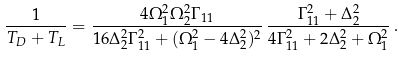Convert formula to latex. <formula><loc_0><loc_0><loc_500><loc_500>\frac { 1 } { T _ { D } + T _ { L } } = \frac { 4 \Omega _ { 1 } ^ { 2 } \Omega _ { 2 } ^ { 2 } \Gamma _ { 1 1 } } { 1 6 \Delta _ { 2 } ^ { 2 } \Gamma _ { 1 1 } ^ { 2 } + ( \Omega _ { 1 } ^ { 2 } - 4 \Delta _ { 2 } ^ { 2 } ) ^ { 2 } } \, \frac { \Gamma _ { 1 1 } ^ { 2 } + \Delta _ { 2 } ^ { 2 } } { 4 \Gamma _ { 1 1 } ^ { 2 } + 2 \Delta _ { 2 } ^ { 2 } + \Omega _ { 1 } ^ { 2 } } \, .</formula> 